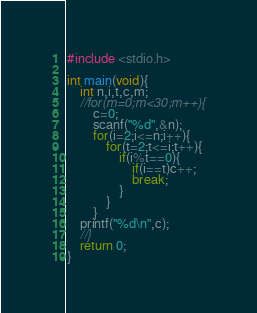Convert code to text. <code><loc_0><loc_0><loc_500><loc_500><_C_>#include <stdio.h>

int main(void){
	int n,i,t,c,m;
	//for(m=0;m<30;m++){
		c=0;
		scanf("%d",&n);
		for(i=2;i<=n;i++){
			for(t=2;t<=i;t++){
				if(i%t==0){
					if(i==t)c++;
					break;
				}
			}
		}
	printf("%d\n",c);
	//}
	return 0;
}</code> 